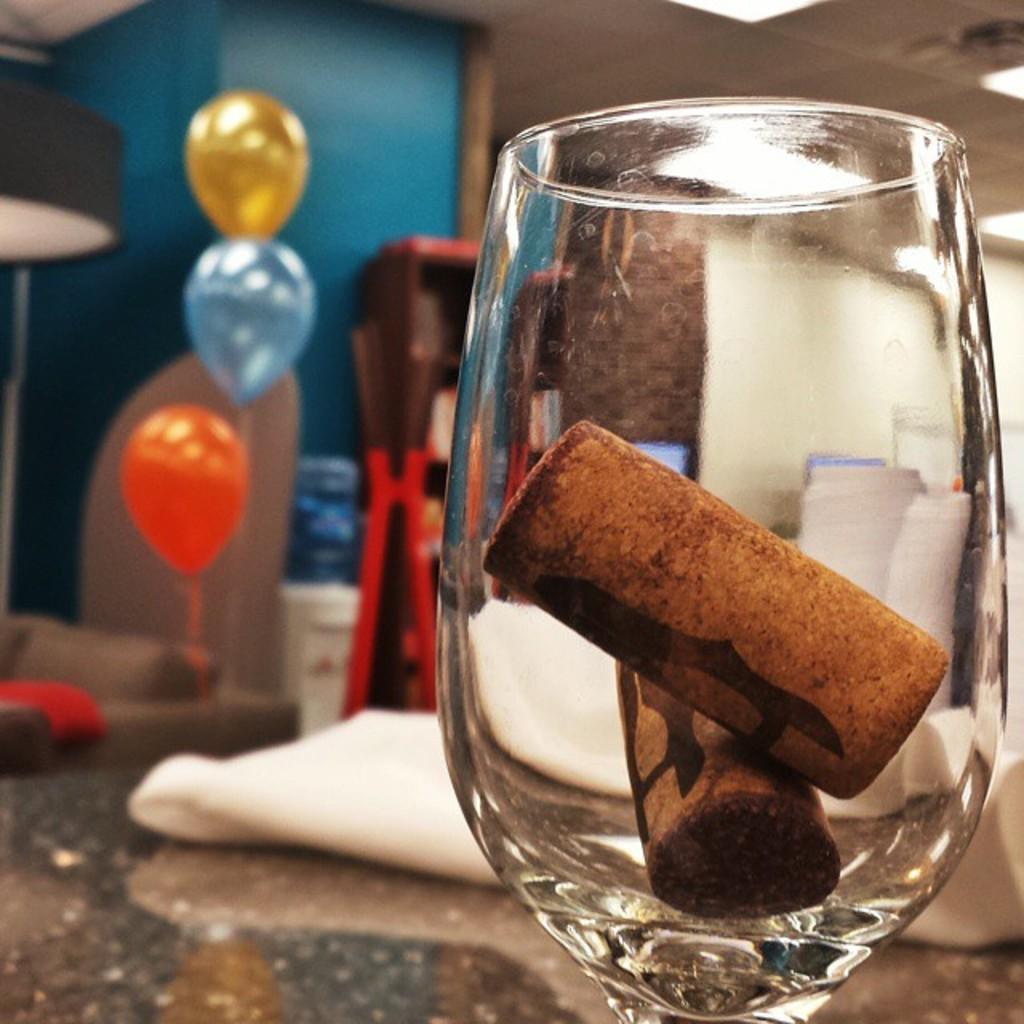How would you summarize this image in a sentence or two? In the foreground of the image there is glass in which there is some object. In the background of the image there is wall. There are balloons. There is a sofa and there are other objects. 